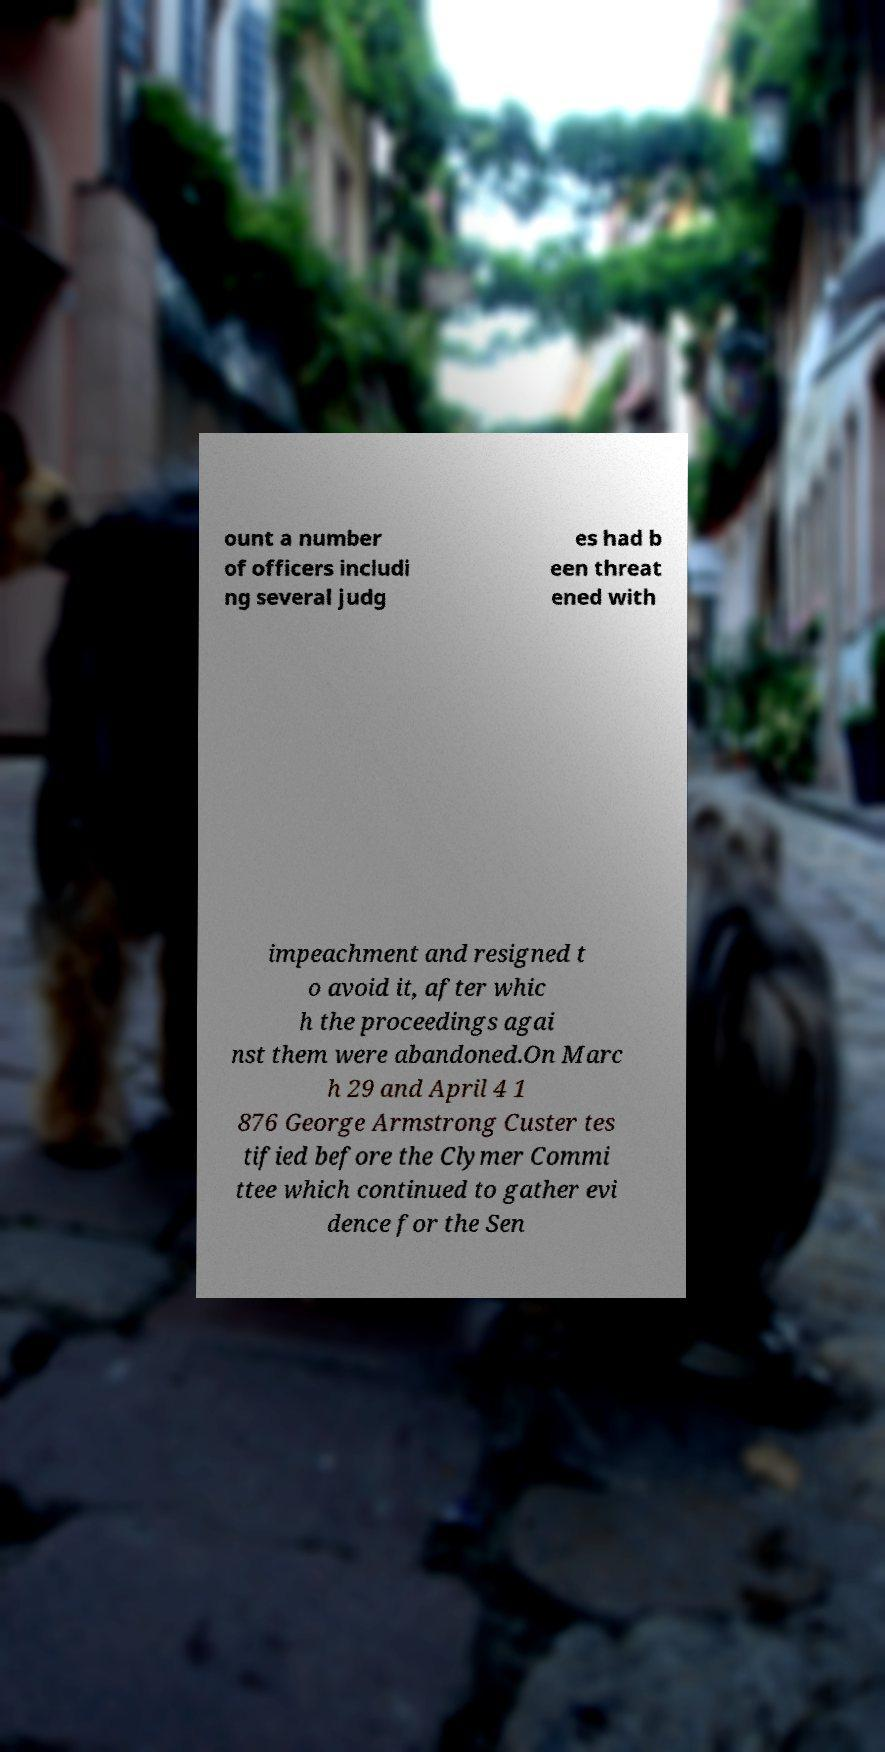Please read and relay the text visible in this image. What does it say? ount a number of officers includi ng several judg es had b een threat ened with impeachment and resigned t o avoid it, after whic h the proceedings agai nst them were abandoned.On Marc h 29 and April 4 1 876 George Armstrong Custer tes tified before the Clymer Commi ttee which continued to gather evi dence for the Sen 